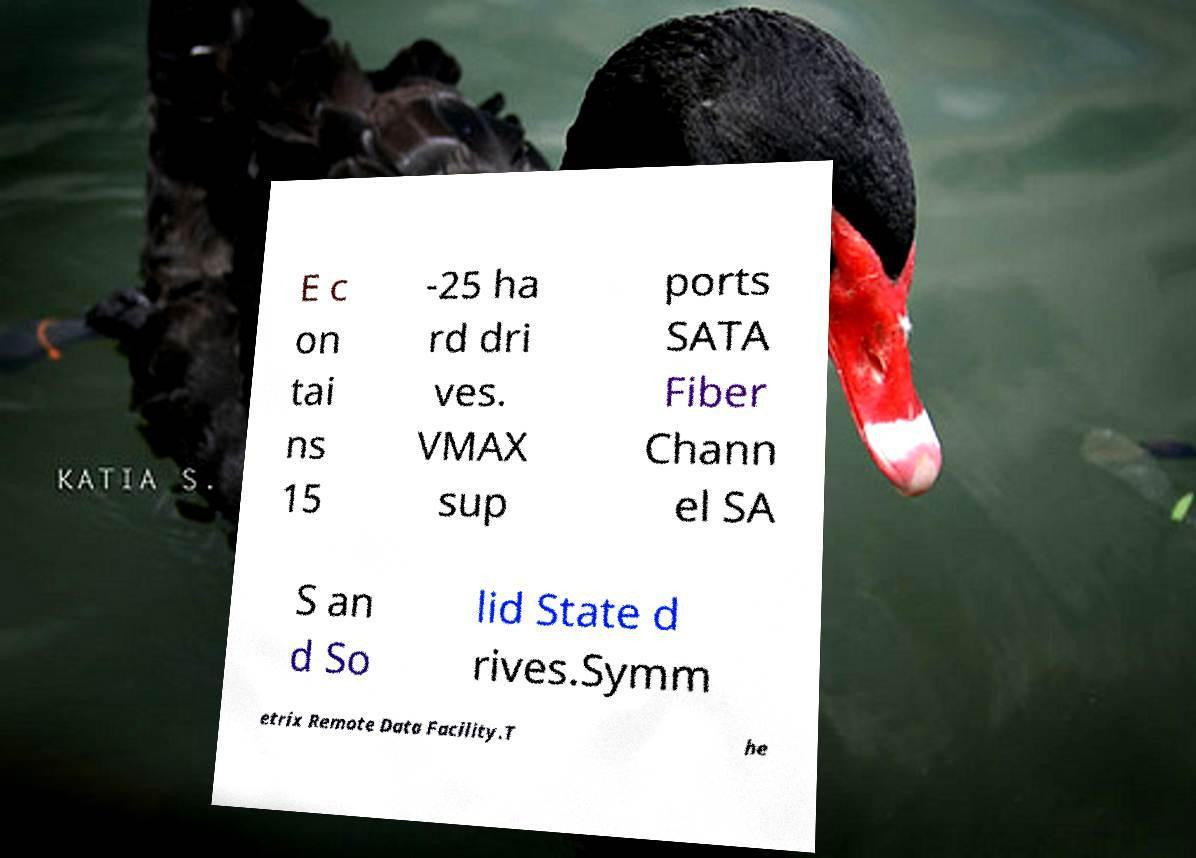Can you accurately transcribe the text from the provided image for me? E c on tai ns 15 -25 ha rd dri ves. VMAX sup ports SATA Fiber Chann el SA S an d So lid State d rives.Symm etrix Remote Data Facility.T he 